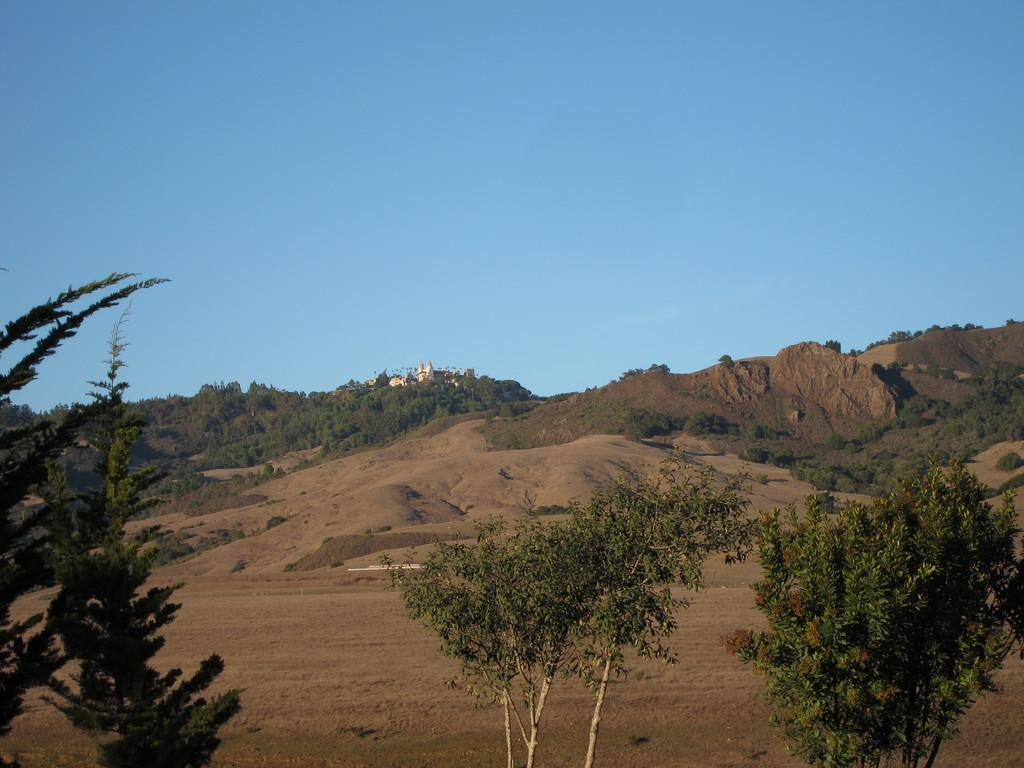What type of vegetation can be seen in the image? There are plants and trees in the image. What type of natural landform is visible in the image? There are hills in the image. What is visible in the background of the image? The sky is visible in the image. What type of appliance is being used to expand the plants in the image? There is no appliance present in the image, and the plants are not being expanded. 